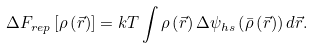Convert formula to latex. <formula><loc_0><loc_0><loc_500><loc_500>\Delta F _ { r e p } \left [ \rho \left ( \vec { r } \right ) \right ] = k T \int \rho \left ( \vec { r } \right ) \Delta \psi _ { h s } \left ( \bar { \rho } \left ( \vec { r } \right ) \right ) d \vec { r } .</formula> 